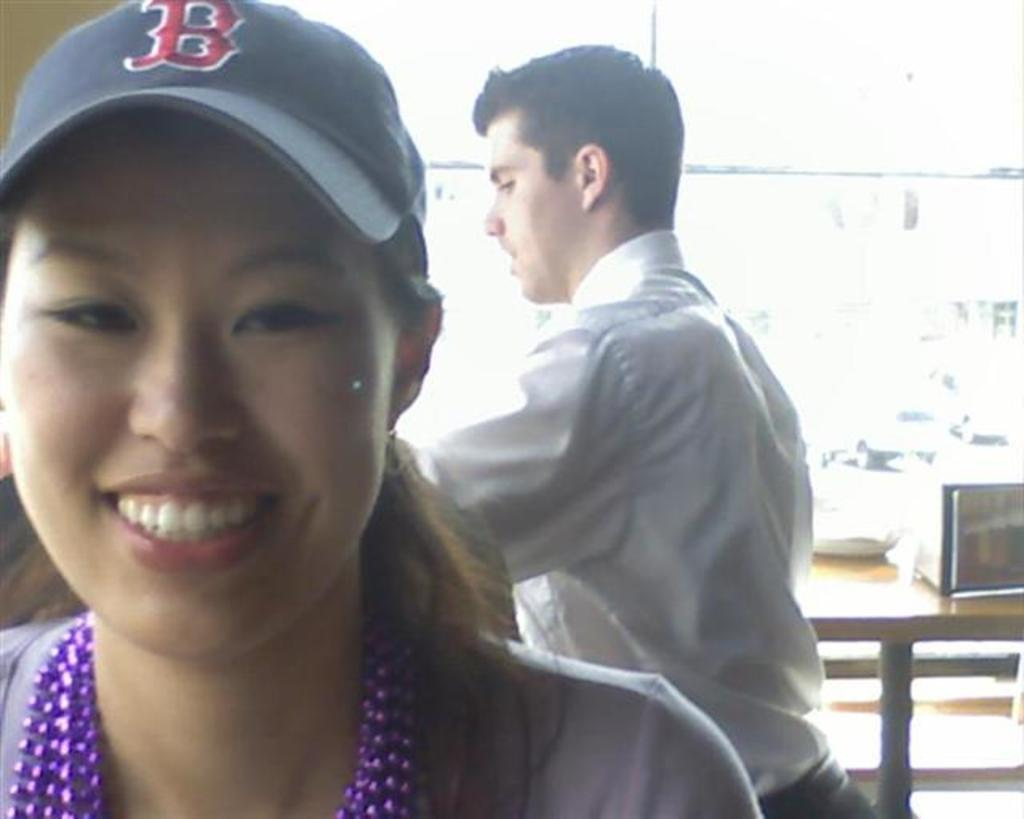<image>
Share a concise interpretation of the image provided. the letter B is on the hat of the lady 